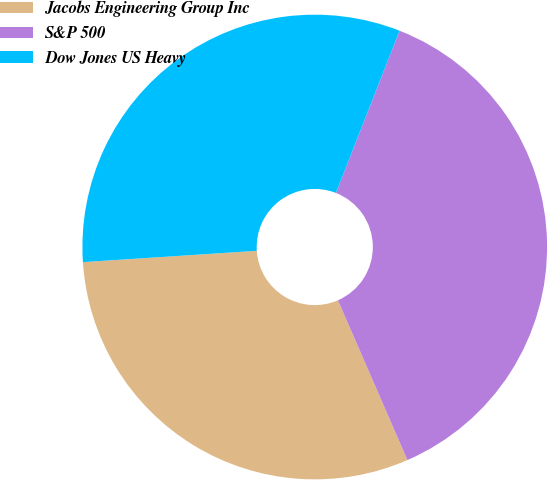<chart> <loc_0><loc_0><loc_500><loc_500><pie_chart><fcel>Jacobs Engineering Group Inc<fcel>S&P 500<fcel>Dow Jones US Heavy<nl><fcel>30.49%<fcel>37.52%<fcel>31.98%<nl></chart> 